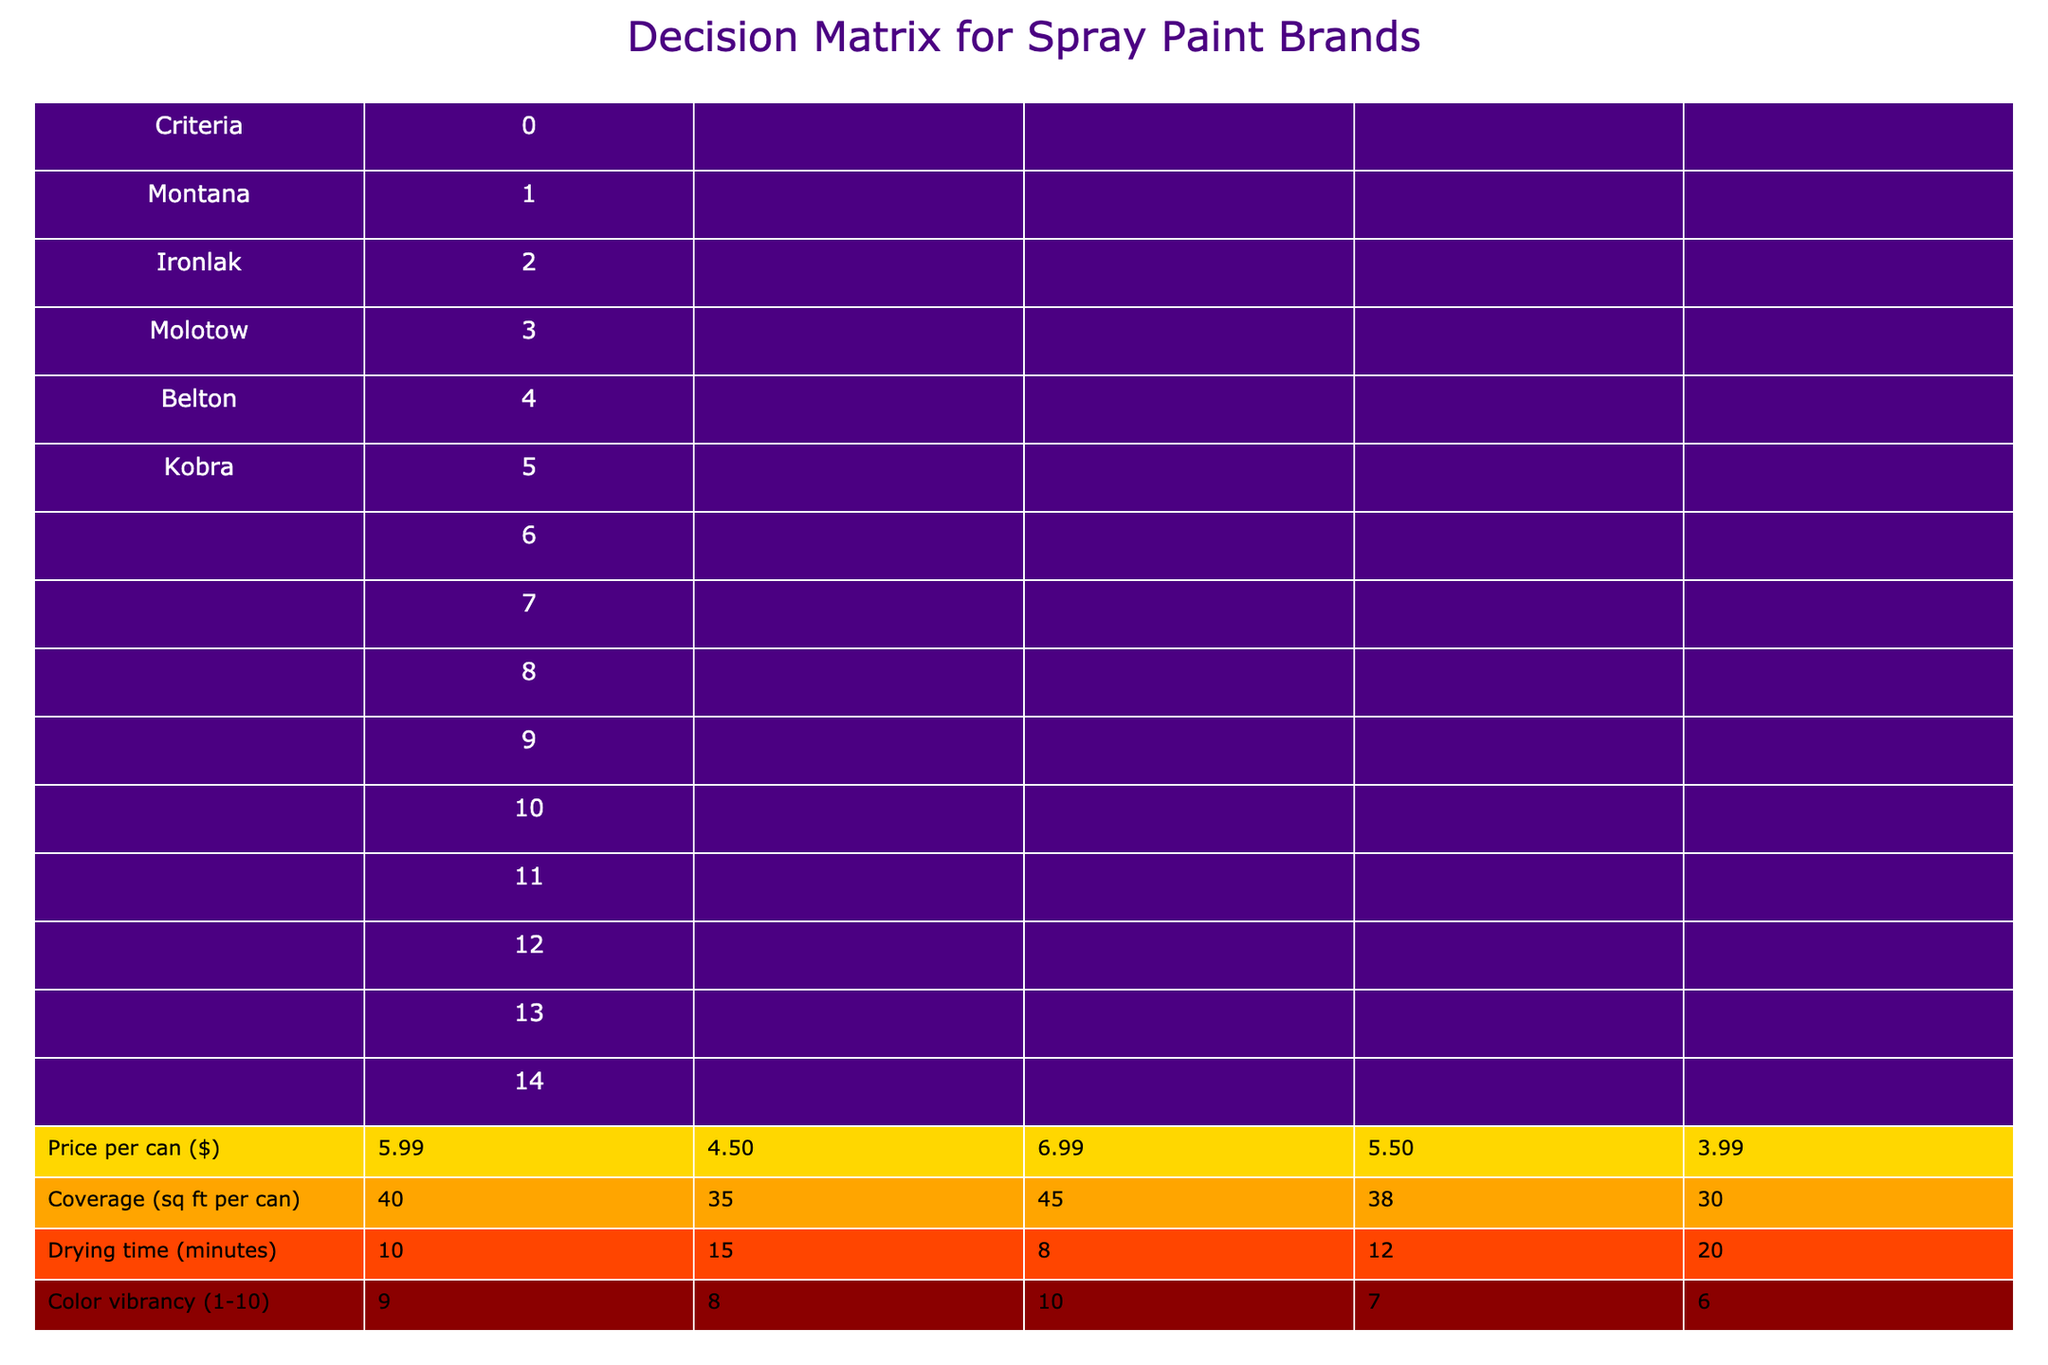What spray paint brand has the lowest price per can? By examining the "Price per can ($)" row, Kobra has the lowest price at $3.99.
Answer: Kobra Which paint brand has the highest coverage per can? The "Coverage (sq ft per can)" values show that Molotow has the highest coverage at 45 sq ft.
Answer: Molotow Do all brands have options suitable for murals? Checking the "Suitable for murals" column, both Belton and Kobra do not have options suitable for murals, so not all brands meet this criterion.
Answer: No What is the average drying time of all the brands? Summing the drying times: 10 + 15 + 8 + 12 + 20 = 65, then dividing by the number of brands (5) gives an average drying time of 65/5 = 13 minutes.
Answer: 13 minutes Which brand has the best color vibrancy and what is its score? Reviewing the "Color vibrancy (1-10)" column, Molotow has the highest score of 10.
Answer: Molotow, 10 Is Eco-friendliness a strong point for any of the brands? The maximum score in the "Eco-friendliness (1-10)" column is 7 for Molotow, indicating it is considered eco-friendly compared to others.
Answer: Yes, Molotow Which paint brand has the highest number of nozzle options? By looking at the "Nozzle options" column, Montana has the highest number with 5 options.
Answer: Montana What are the differences in UV resistance between the best and worst brands? The best UV resistance is 9 from Molotow, while the worst is 6 from Kobra; the difference is 9 - 6 = 3.
Answer: 3 Can you find a brand that is both eco-friendly and available in high stock in Oakland? From the "Eco-friendliness (1-10)" and "Availability in Oakland" columns, both Montana and Molotow have sufficiently high scores (6 and 7) and are available in high stock.
Answer: Yes, Montana and Molotow 